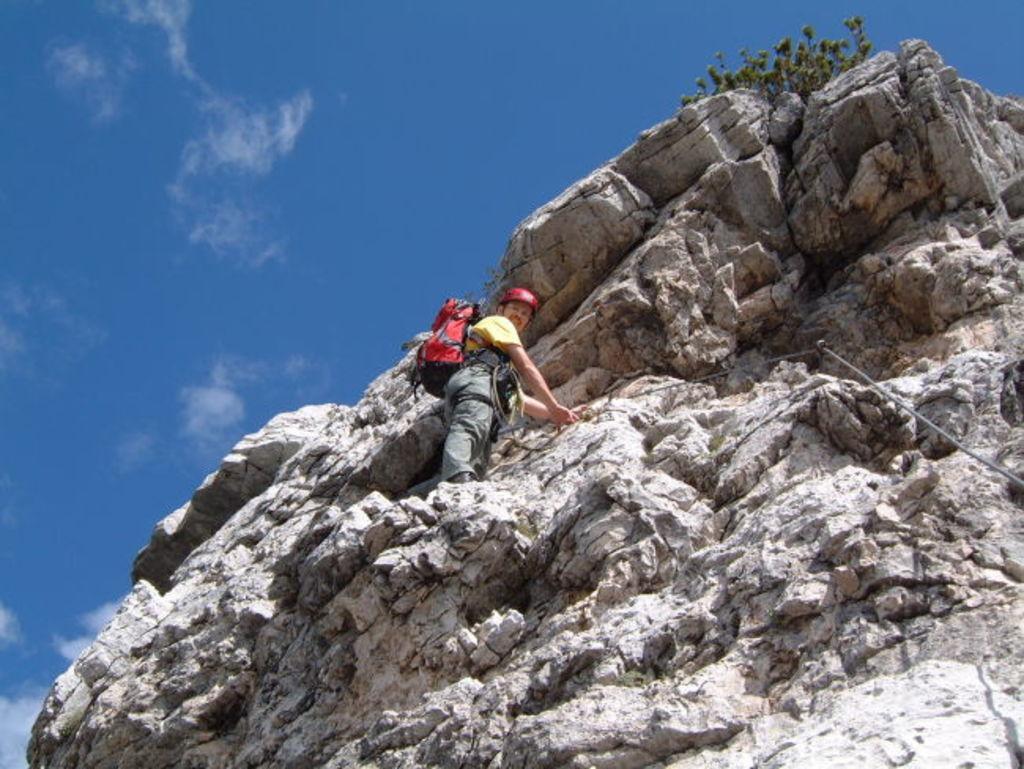In one or two sentences, can you explain what this image depicts? In this image there is a person standing on the mountain, and in the background there is sky. 